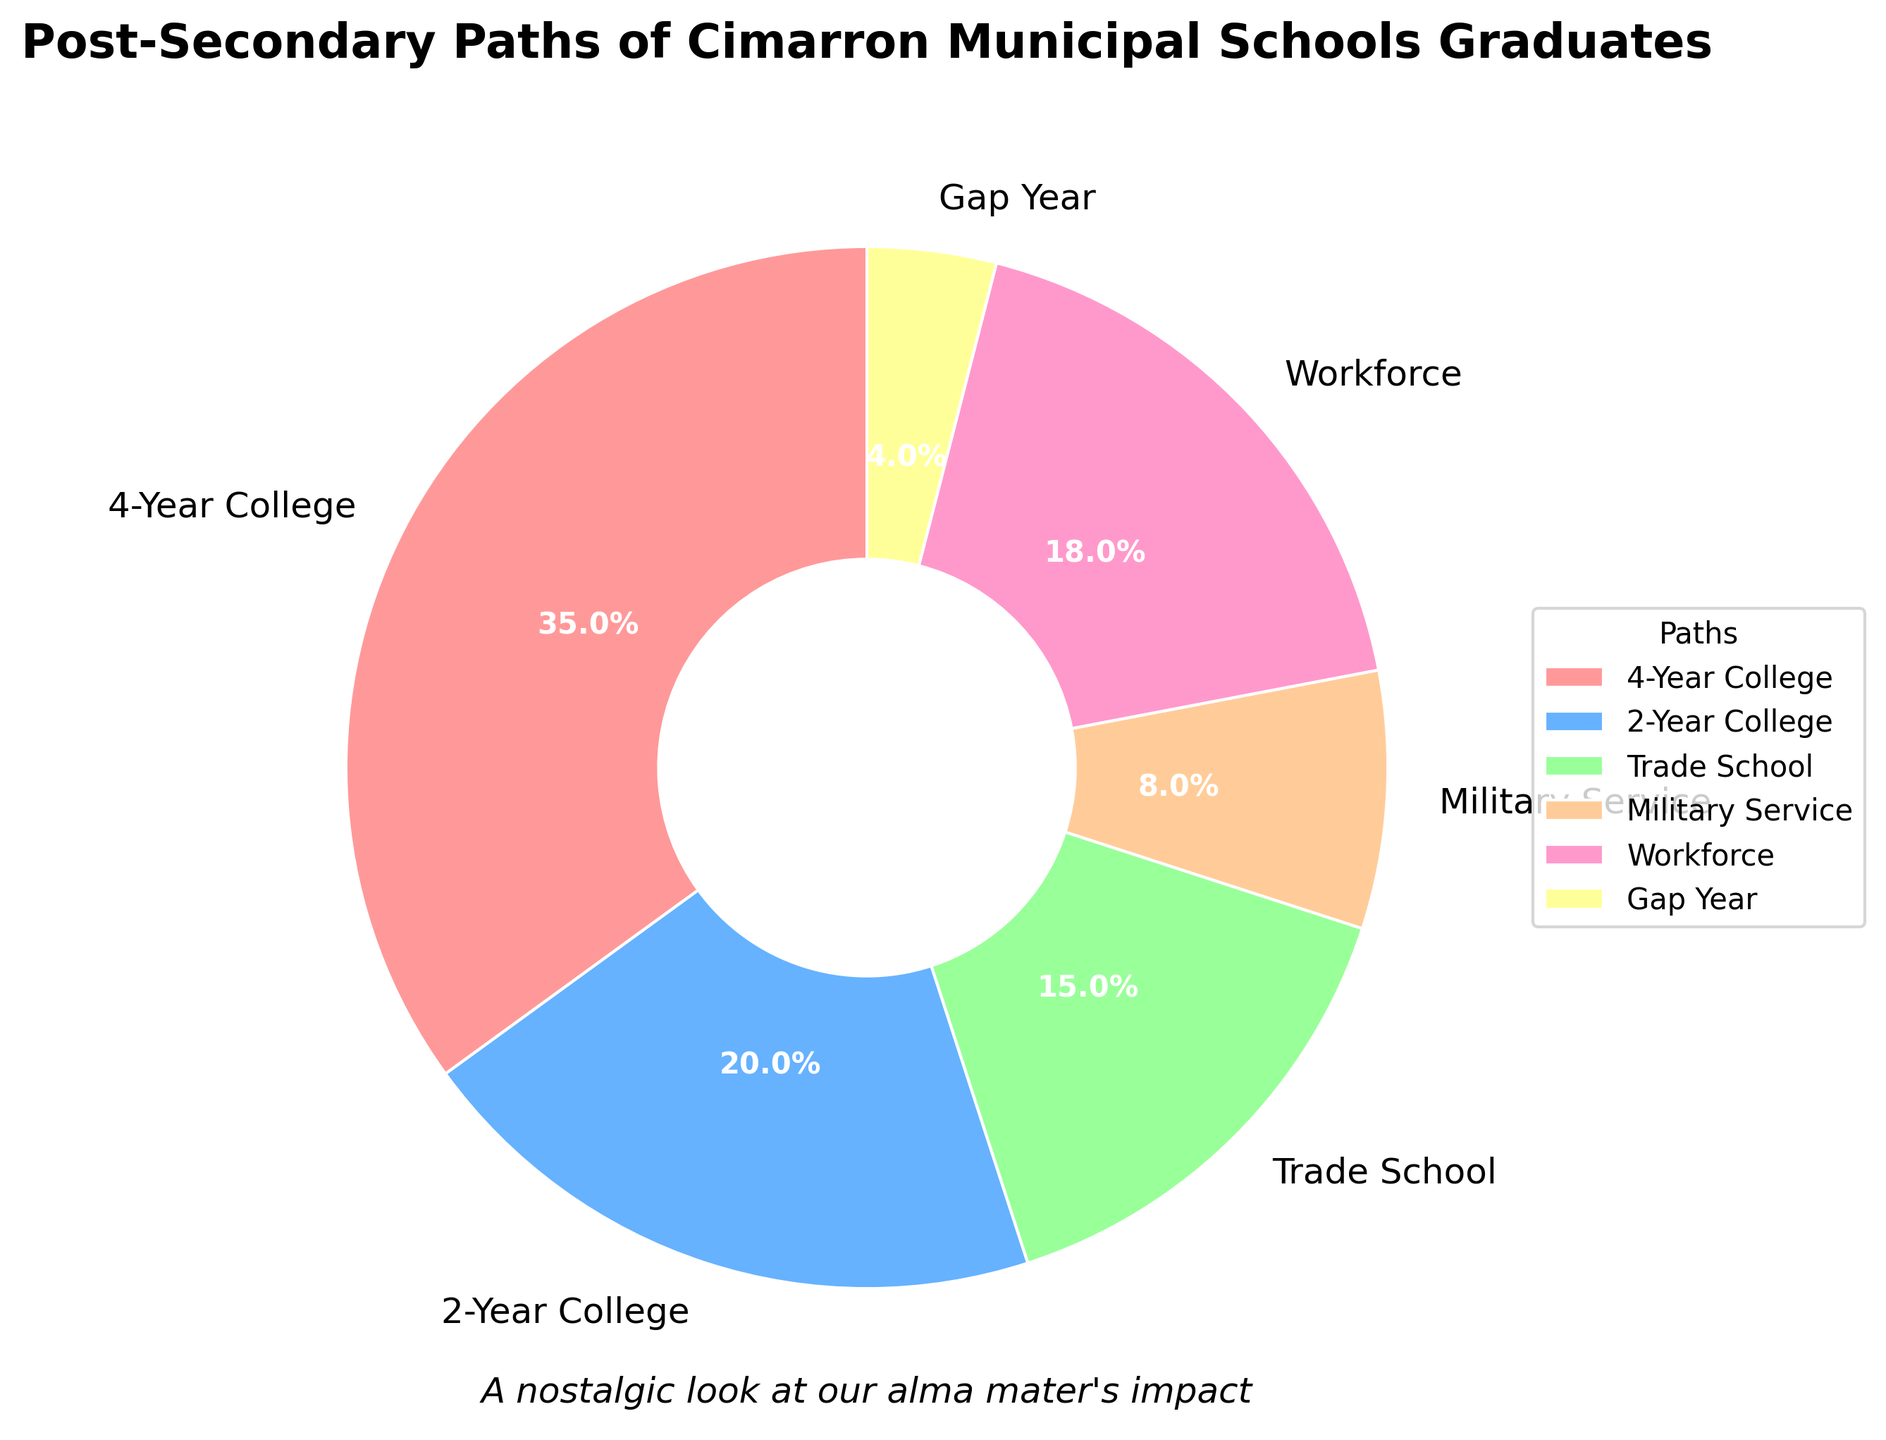Which post-secondary path is chosen by most graduates? The largest segment in the pie chart is labeled "4-Year College," which covers 35% of the chart, indicating that this path is chosen by most graduates.
Answer: 4-Year College What percentage of graduates enter the workforce directly? The segment labeled "Workforce" represents 18% of the chart, indicating the percentage of graduates who enter the workforce directly.
Answer: 18% How many percentage points more graduates pursue a 4-year college compared to a 2-year college? The segment for "4-Year College" is 35%, and the segment for "2-Year College" is 20%. The difference is 35% - 20% = 15 percentage points.
Answer: 15 percentage points Which two post-secondary paths have the closest percentages? The segments for "Trade School" (15%) and "Workforce" (18%) are closest in percentage, with a difference of only 3 percentage points.
Answer: Trade School and Workforce What is the combined percentage of graduates going into either the military or taking a gap year? The segment for "Military Service" is 8% and the segment for "Gap Year" is 4%. Their combined percentage is 8% + 4% = 12%.
Answer: 12% Does the percentage of graduates going to trade school exceed those taking a gap year by more than 10 percentage points? The segment for "Trade School" is 15%, and the segment for "Gap Year" is 4%. The difference is 15% - 4% = 11 percentage points, which exceeds 10 percentage points.
Answer: Yes How do the percentages of graduates attending a 2-year college compare to those going directly into the workforce? The segment for "2-Year College" is 20%, while the segment for "Workforce" is 18%. The percentage for "2-Year College" exceeds "Workforce" by 2 percentage points.
Answer: 2-Year College exceeds Workforce by 2 percentage points Is the percentage of graduates joining the military higher or lower than those taking a gap year? The segment for "Military Service" is 8%, while the segment for "Gap Year" is 4%. Therefore, the percentage of graduates joining the military is higher.
Answer: Higher What's the total percentage of graduates pursuing either college (2-Year or 4-Year)? The segment for "4-Year College" is 35%, and the segment for "2-Year College" is 20%. Their total is 35% + 20% = 55%.
Answer: 55% Which segment is represented by a yellow color in the pie chart? The yellow color segment represents "Gap Year," which accounts for 4% of graduates.
Answer: Gap Year 